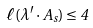<formula> <loc_0><loc_0><loc_500><loc_500>\ell ( \lambda ^ { \prime } \cdot A _ { s } ) \leq 4</formula> 